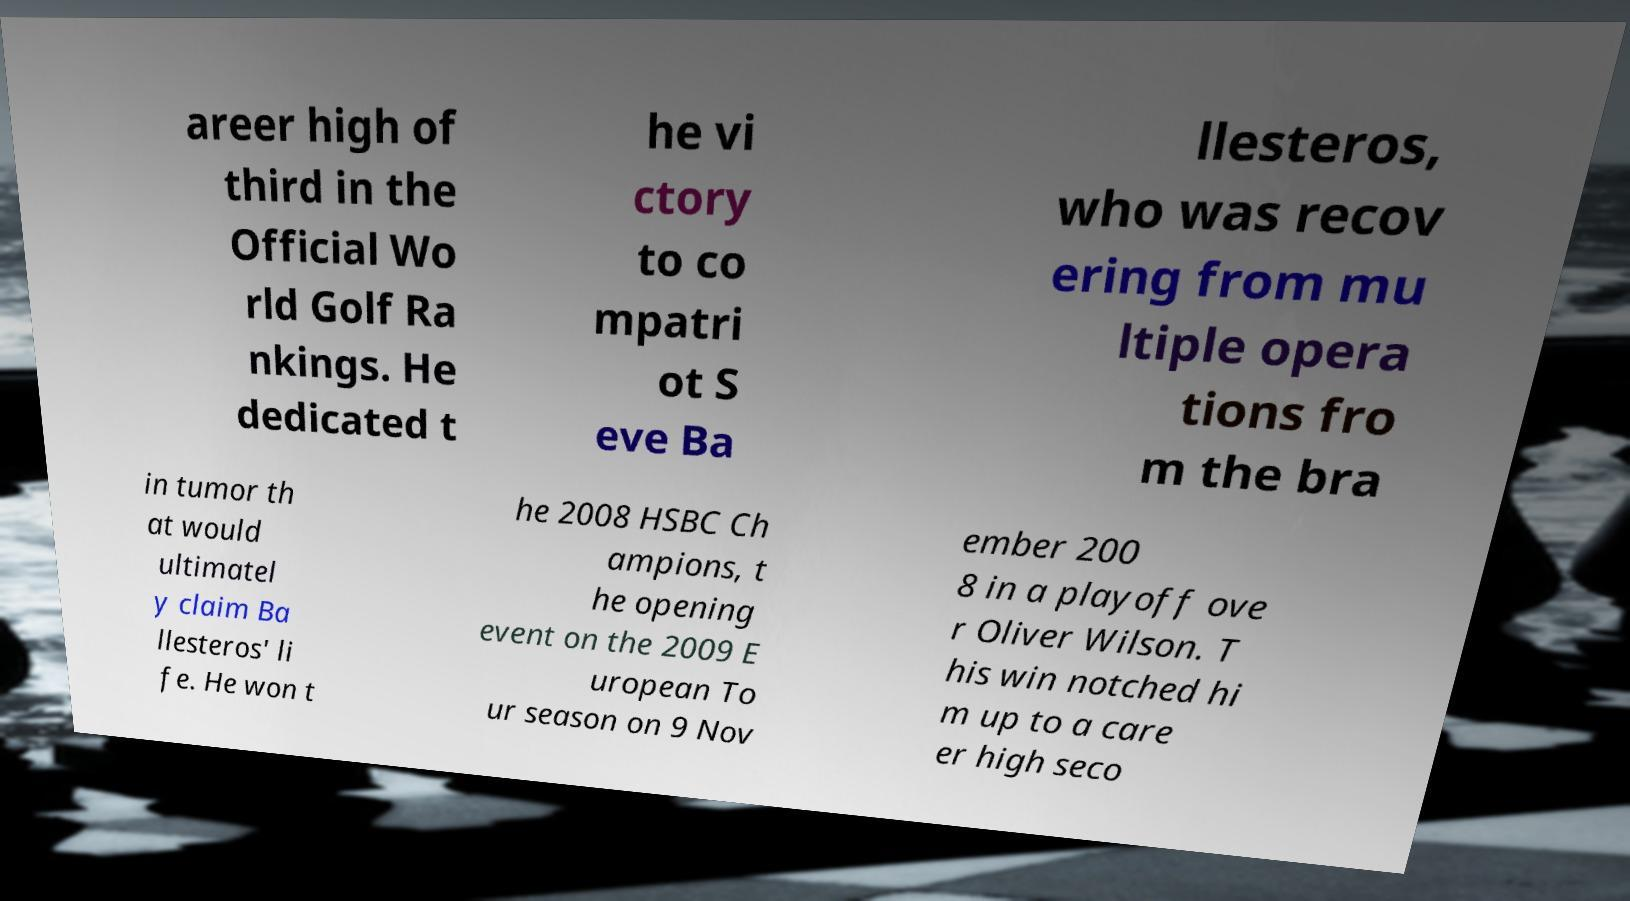Please identify and transcribe the text found in this image. areer high of third in the Official Wo rld Golf Ra nkings. He dedicated t he vi ctory to co mpatri ot S eve Ba llesteros, who was recov ering from mu ltiple opera tions fro m the bra in tumor th at would ultimatel y claim Ba llesteros' li fe. He won t he 2008 HSBC Ch ampions, t he opening event on the 2009 E uropean To ur season on 9 Nov ember 200 8 in a playoff ove r Oliver Wilson. T his win notched hi m up to a care er high seco 